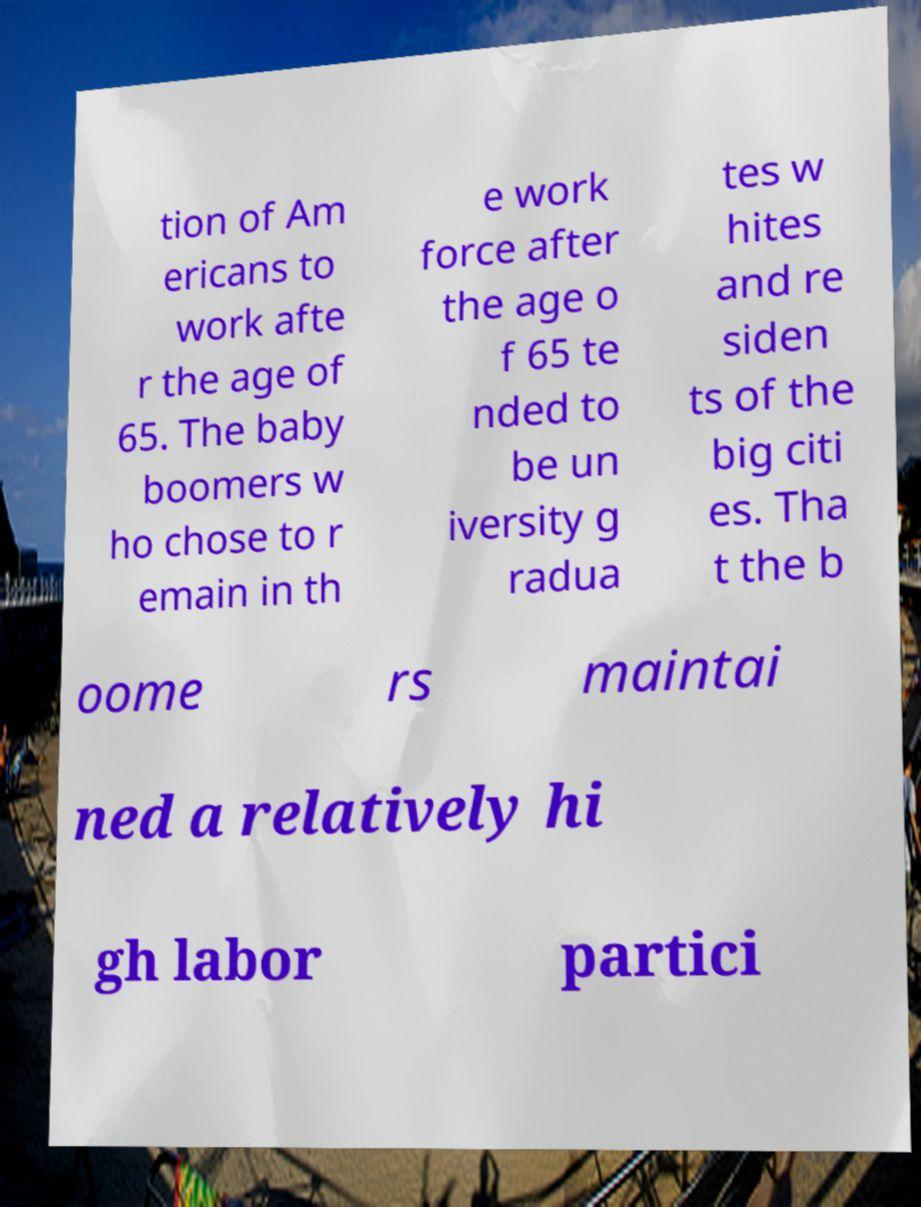Please identify and transcribe the text found in this image. tion of Am ericans to work afte r the age of 65. The baby boomers w ho chose to r emain in th e work force after the age o f 65 te nded to be un iversity g radua tes w hites and re siden ts of the big citi es. Tha t the b oome rs maintai ned a relatively hi gh labor partici 